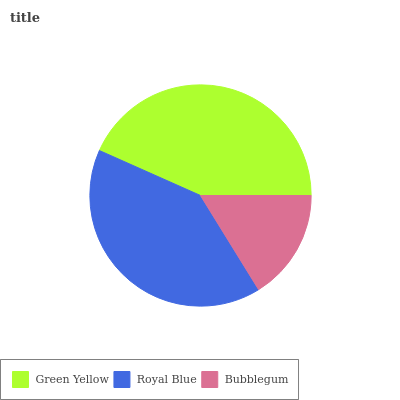Is Bubblegum the minimum?
Answer yes or no. Yes. Is Green Yellow the maximum?
Answer yes or no. Yes. Is Royal Blue the minimum?
Answer yes or no. No. Is Royal Blue the maximum?
Answer yes or no. No. Is Green Yellow greater than Royal Blue?
Answer yes or no. Yes. Is Royal Blue less than Green Yellow?
Answer yes or no. Yes. Is Royal Blue greater than Green Yellow?
Answer yes or no. No. Is Green Yellow less than Royal Blue?
Answer yes or no. No. Is Royal Blue the high median?
Answer yes or no. Yes. Is Royal Blue the low median?
Answer yes or no. Yes. Is Green Yellow the high median?
Answer yes or no. No. Is Green Yellow the low median?
Answer yes or no. No. 